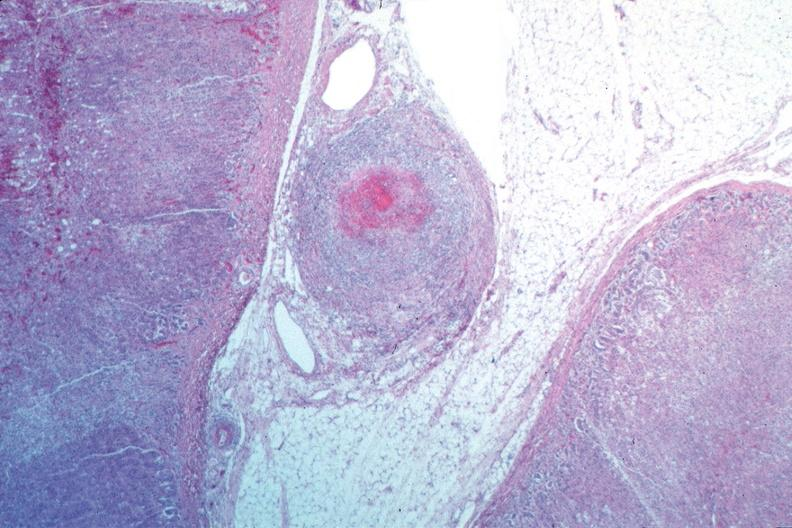s cardiovascular present?
Answer the question using a single word or phrase. Yes 